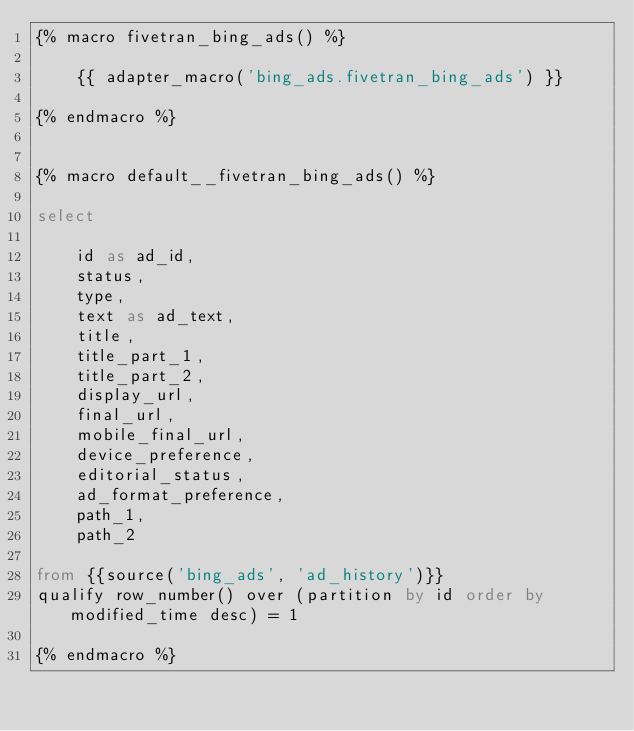Convert code to text. <code><loc_0><loc_0><loc_500><loc_500><_SQL_>{% macro fivetran_bing_ads() %}

    {{ adapter_macro('bing_ads.fivetran_bing_ads') }}

{% endmacro %}


{% macro default__fivetran_bing_ads() %}

select 

    id as ad_id,
    status,
    type,
    text as ad_text,
    title,
    title_part_1,
    title_part_2,
    display_url,
    final_url,    
    mobile_final_url,
    device_preference,
    editorial_status,
    ad_format_preference,
    path_1,
    path_2

from {{source('bing_ads', 'ad_history')}}
qualify row_number() over (partition by id order by modified_time desc) = 1

{% endmacro %}</code> 